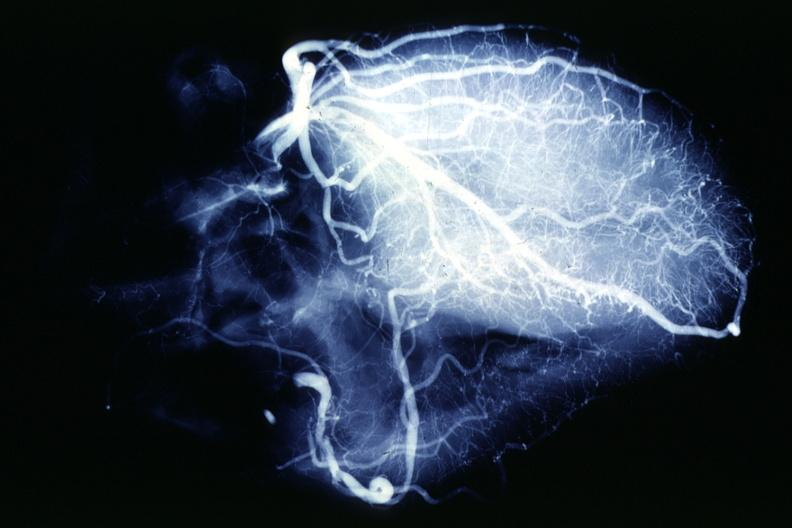s breast present?
Answer the question using a single word or phrase. No 